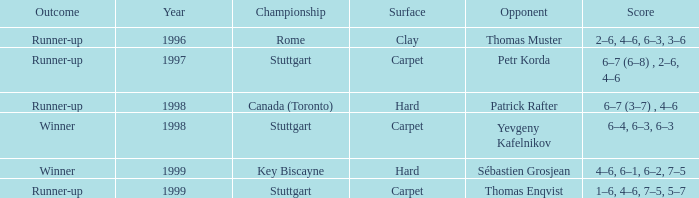What was the surface in 1996? Clay. 